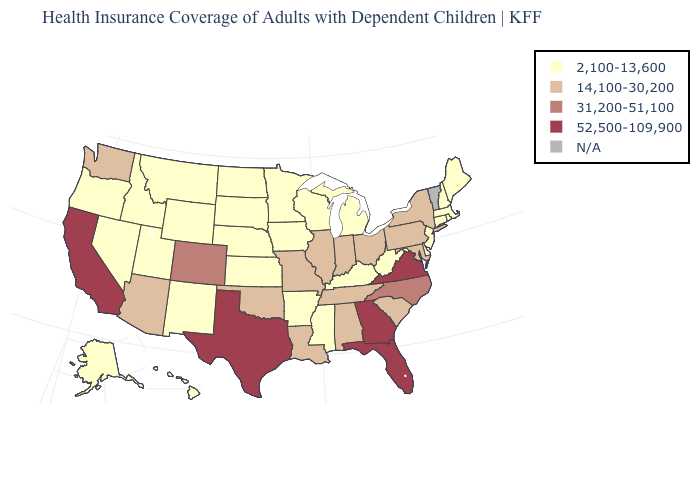Does New Mexico have the lowest value in the West?
Quick response, please. Yes. Does the first symbol in the legend represent the smallest category?
Answer briefly. Yes. Name the states that have a value in the range 14,100-30,200?
Write a very short answer. Alabama, Arizona, Illinois, Indiana, Louisiana, Maryland, Missouri, New York, Ohio, Oklahoma, Pennsylvania, South Carolina, Tennessee, Washington. Which states have the lowest value in the USA?
Concise answer only. Alaska, Arkansas, Connecticut, Delaware, Hawaii, Idaho, Iowa, Kansas, Kentucky, Maine, Massachusetts, Michigan, Minnesota, Mississippi, Montana, Nebraska, Nevada, New Hampshire, New Jersey, New Mexico, North Dakota, Oregon, Rhode Island, South Dakota, Utah, West Virginia, Wisconsin, Wyoming. Name the states that have a value in the range 31,200-51,100?
Answer briefly. Colorado, North Carolina. Which states have the lowest value in the West?
Short answer required. Alaska, Hawaii, Idaho, Montana, Nevada, New Mexico, Oregon, Utah, Wyoming. Name the states that have a value in the range 14,100-30,200?
Give a very brief answer. Alabama, Arizona, Illinois, Indiana, Louisiana, Maryland, Missouri, New York, Ohio, Oklahoma, Pennsylvania, South Carolina, Tennessee, Washington. Name the states that have a value in the range 52,500-109,900?
Concise answer only. California, Florida, Georgia, Texas, Virginia. Name the states that have a value in the range N/A?
Give a very brief answer. Vermont. What is the value of New Hampshire?
Be succinct. 2,100-13,600. Among the states that border New York , which have the highest value?
Be succinct. Pennsylvania. What is the value of Kansas?
Give a very brief answer. 2,100-13,600. What is the value of Illinois?
Give a very brief answer. 14,100-30,200. 